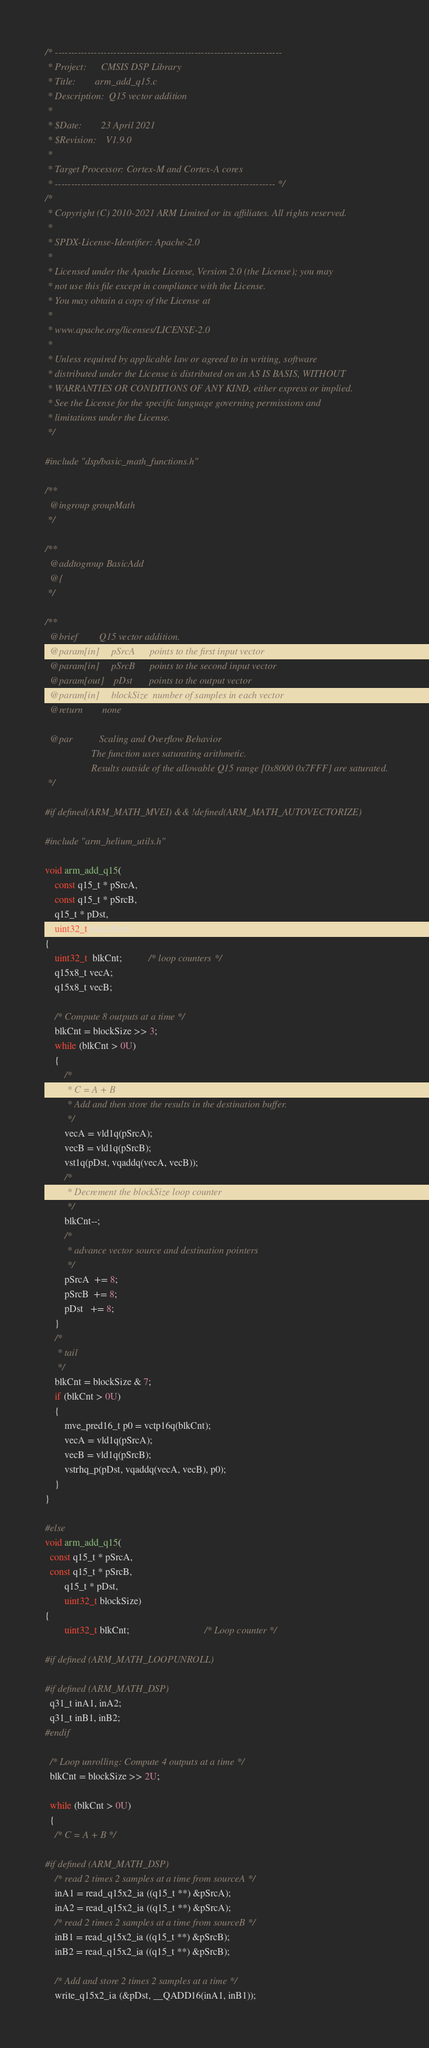<code> <loc_0><loc_0><loc_500><loc_500><_C_>/* ----------------------------------------------------------------------
 * Project:      CMSIS DSP Library
 * Title:        arm_add_q15.c
 * Description:  Q15 vector addition
 *
 * $Date:        23 April 2021
 * $Revision:    V1.9.0
 *
 * Target Processor: Cortex-M and Cortex-A cores
 * -------------------------------------------------------------------- */
/*
 * Copyright (C) 2010-2021 ARM Limited or its affiliates. All rights reserved.
 *
 * SPDX-License-Identifier: Apache-2.0
 *
 * Licensed under the Apache License, Version 2.0 (the License); you may
 * not use this file except in compliance with the License.
 * You may obtain a copy of the License at
 *
 * www.apache.org/licenses/LICENSE-2.0
 *
 * Unless required by applicable law or agreed to in writing, software
 * distributed under the License is distributed on an AS IS BASIS, WITHOUT
 * WARRANTIES OR CONDITIONS OF ANY KIND, either express or implied.
 * See the License for the specific language governing permissions and
 * limitations under the License.
 */

#include "dsp/basic_math_functions.h"

/**
  @ingroup groupMath
 */

/**
  @addtogroup BasicAdd
  @{
 */

/**
  @brief         Q15 vector addition.
  @param[in]     pSrcA      points to the first input vector
  @param[in]     pSrcB      points to the second input vector
  @param[out]    pDst       points to the output vector
  @param[in]     blockSize  number of samples in each vector
  @return        none

  @par           Scaling and Overflow Behavior
                   The function uses saturating arithmetic.
                   Results outside of the allowable Q15 range [0x8000 0x7FFF] are saturated.
 */

#if defined(ARM_MATH_MVEI) && !defined(ARM_MATH_AUTOVECTORIZE)

#include "arm_helium_utils.h"

void arm_add_q15(
    const q15_t * pSrcA,
    const q15_t * pSrcB,
    q15_t * pDst,
    uint32_t blockSize)
{
    uint32_t  blkCnt;           /* loop counters */
    q15x8_t vecA;
    q15x8_t vecB;

    /* Compute 8 outputs at a time */
    blkCnt = blockSize >> 3;
    while (blkCnt > 0U)
    {
        /*
         * C = A + B
         * Add and then store the results in the destination buffer.
         */
        vecA = vld1q(pSrcA);
        vecB = vld1q(pSrcB);
        vst1q(pDst, vqaddq(vecA, vecB));
        /*
         * Decrement the blockSize loop counter
         */
        blkCnt--;
        /*
         * advance vector source and destination pointers
         */
        pSrcA  += 8;
        pSrcB  += 8;
        pDst   += 8;
    }
    /*
     * tail
     */
    blkCnt = blockSize & 7;
    if (blkCnt > 0U)
    {
        mve_pred16_t p0 = vctp16q(blkCnt);
        vecA = vld1q(pSrcA);
        vecB = vld1q(pSrcB);
        vstrhq_p(pDst, vqaddq(vecA, vecB), p0);
    }
}

#else
void arm_add_q15(
  const q15_t * pSrcA,
  const q15_t * pSrcB,
        q15_t * pDst,
        uint32_t blockSize)
{
        uint32_t blkCnt;                               /* Loop counter */

#if defined (ARM_MATH_LOOPUNROLL)

#if defined (ARM_MATH_DSP)
  q31_t inA1, inA2;
  q31_t inB1, inB2;
#endif

  /* Loop unrolling: Compute 4 outputs at a time */
  blkCnt = blockSize >> 2U;

  while (blkCnt > 0U)
  {
    /* C = A + B */

#if defined (ARM_MATH_DSP)
    /* read 2 times 2 samples at a time from sourceA */
    inA1 = read_q15x2_ia ((q15_t **) &pSrcA);
    inA2 = read_q15x2_ia ((q15_t **) &pSrcA);
    /* read 2 times 2 samples at a time from sourceB */
    inB1 = read_q15x2_ia ((q15_t **) &pSrcB);
    inB2 = read_q15x2_ia ((q15_t **) &pSrcB);

    /* Add and store 2 times 2 samples at a time */
    write_q15x2_ia (&pDst, __QADD16(inA1, inB1));</code> 